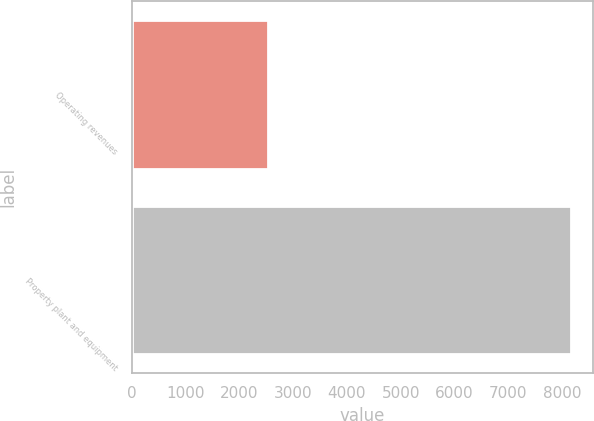Convert chart. <chart><loc_0><loc_0><loc_500><loc_500><bar_chart><fcel>Operating revenues<fcel>Property plant and equipment<nl><fcel>2530<fcel>8172<nl></chart> 